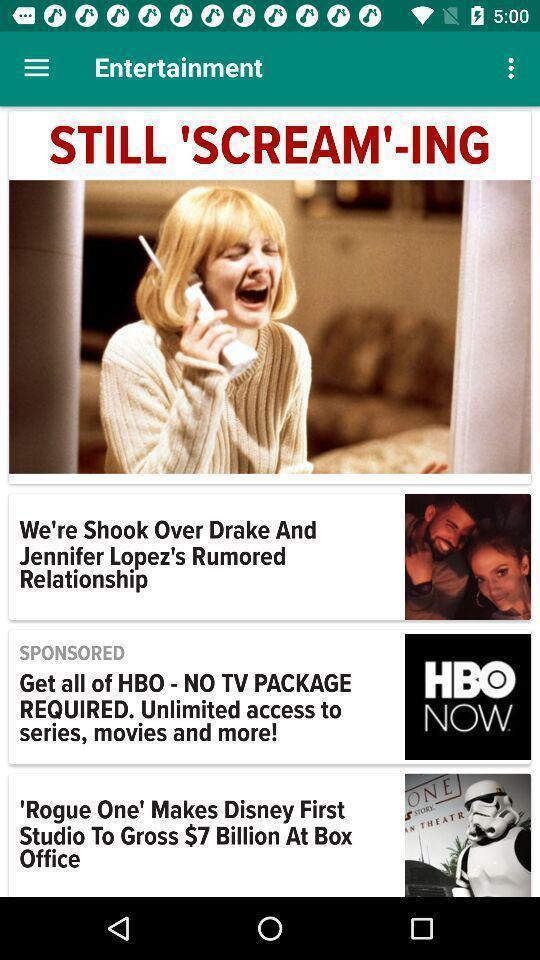What can you discern from this picture? Page displaying various articles. 